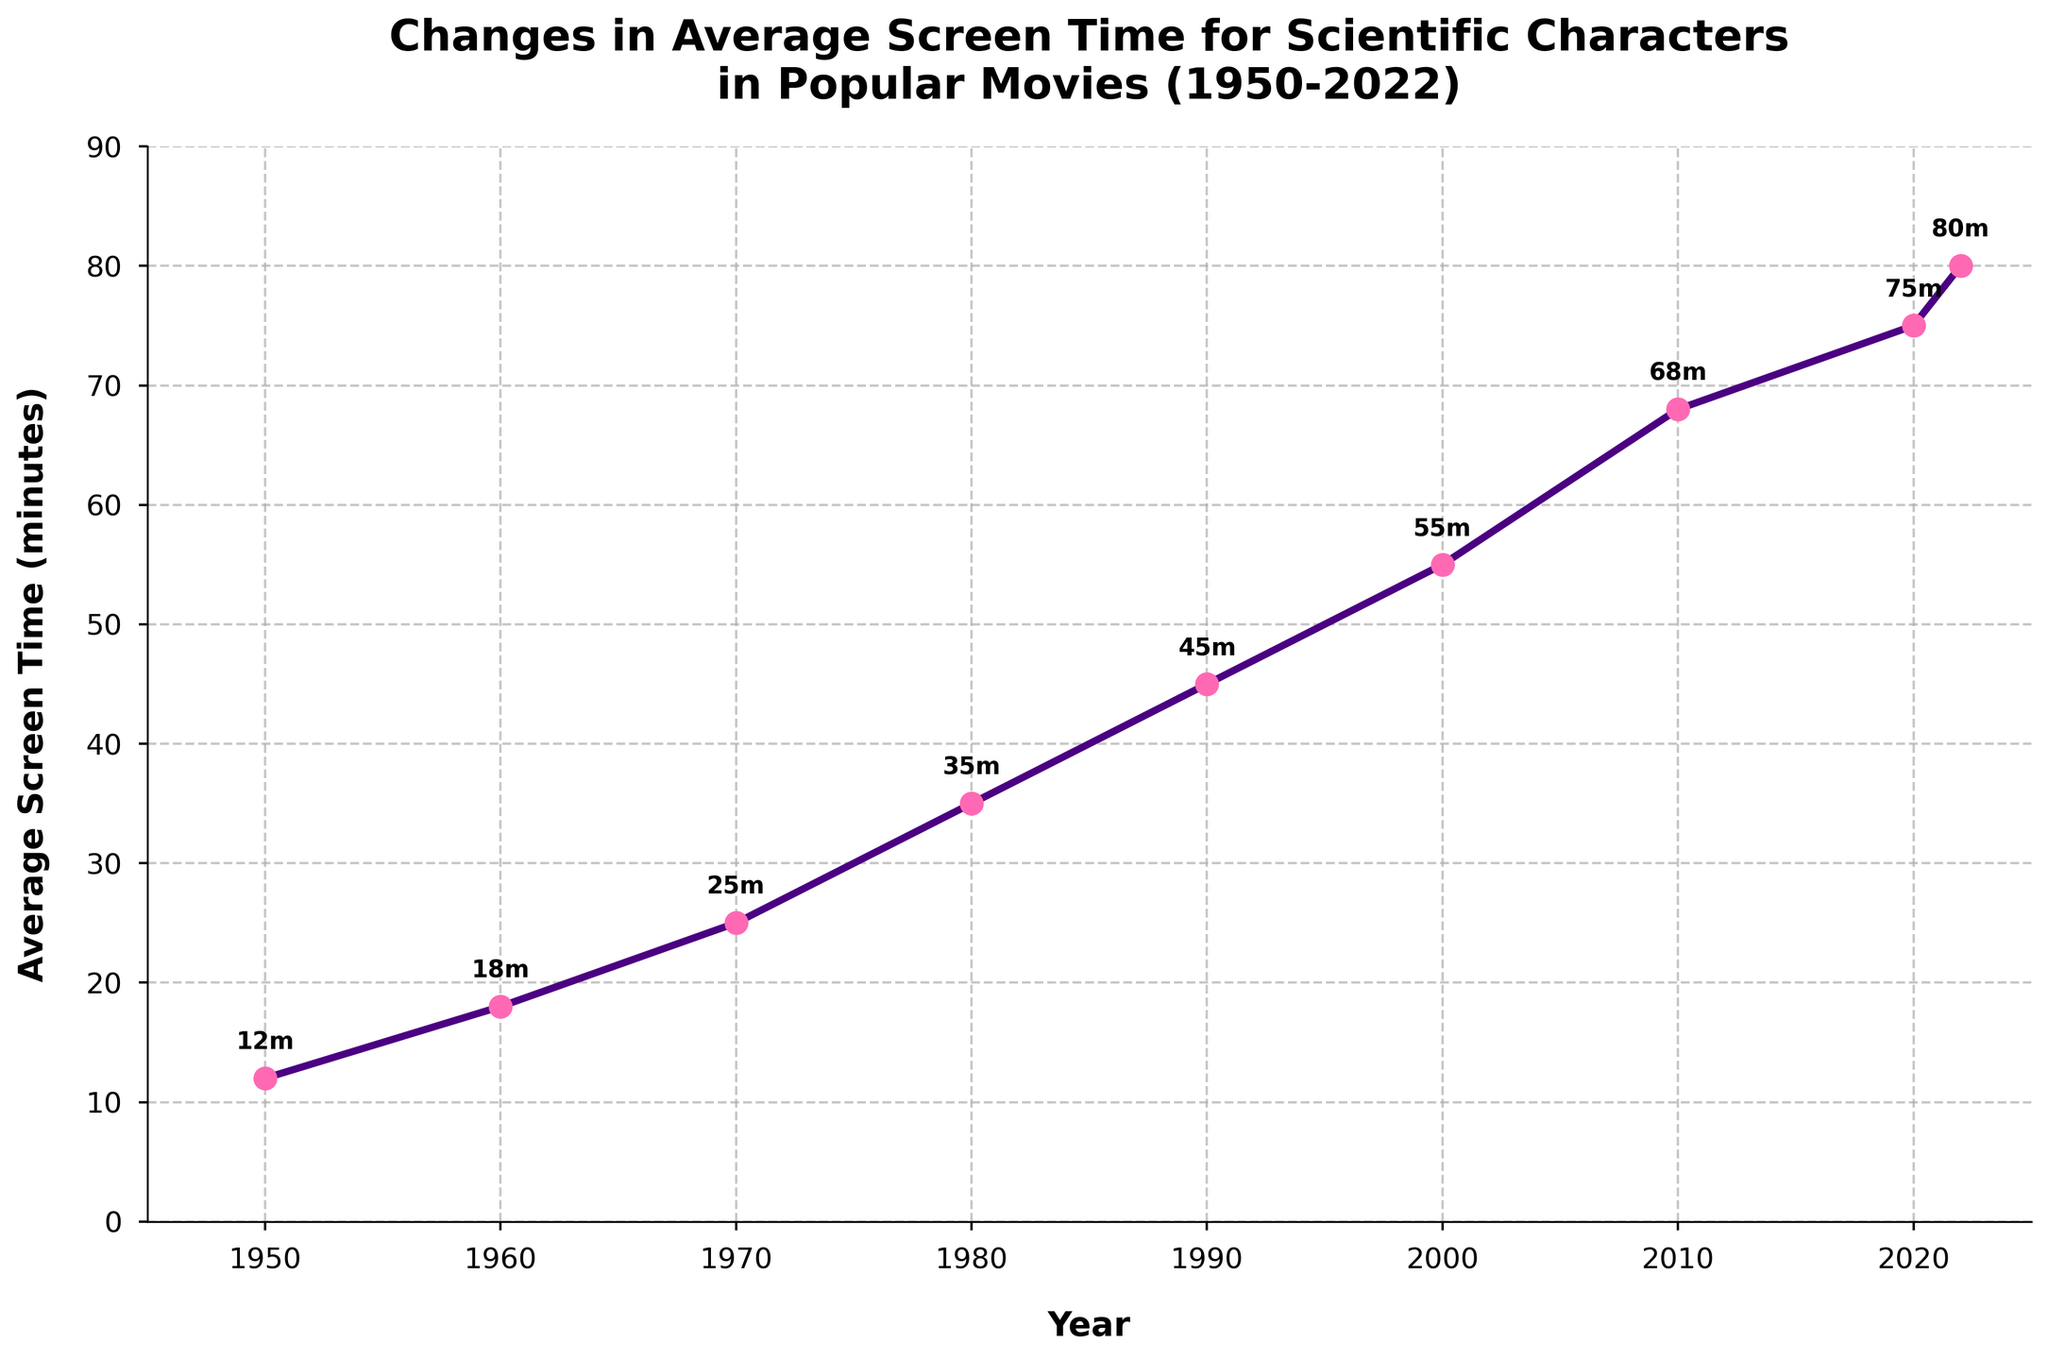What is the average screen time for scientific characters in popular movies in 2020? Look at the data point for the year 2020 on the plot. The y-axis value indicates the screen time for that year.
Answer: 75 minutes How much did the average screen time increase from 1950 to 2022? Identify the screen times for 1950 and 2022, then subtract the 1950 value from the 2022 value. 80 minutes (2022) - 12 minutes (1950) = 68 minutes
Answer: 68 minutes Which decade saw the largest increase in average screen time? Compare the increase in average screen time across decades by examining the data points on the plot. The increase from one decade to the next should be calculated. The 2010 to 2020 decade had an increase from 68 minutes to 75 minutes, and subsequently to 80 minutes in 2022.
Answer: 2010s How does the screen time in 1980 compare to that in 2000? Look at the screen times for the years 1980 and 2000 and compare them.
Answer: 1980 had 35 minutes and 2000 had 55 minutes. The screen time in 2000 is 20 minutes longer than in 1980 What is the overall trend in the average screen time for scientific characters from 1950 to 2022? Observe the general direction of the line plot from 1950 to 2022, noting if it increases, decreases, or remains constant.
Answer: Increasing trend Between which two consecutive data points does the largest single year increase occur? Calculate the difference in screen time for each consecutive year and identify the year with the largest difference. Evaluate changes: (1960-1950), (1970-1960), (1980-1970), etc. The increment is highest from 2010 to 2020 (68m to 75m).
Answer: 2010 to 2020 What is the median screen time of the dataset from 1950 to 2022? List all screen times in ascending order: 12, 18, 25, 35, 45, 55, 68, 75, 80. Since there are 9 values, the median is the middle value.
Answer: 45 minutes By how many minutes did the average screen time increase from 1970 to 1980? Identify the screen times for the years 1970 and 1980, then subtract the 1970 value from the 1980 value. 35 minutes (1980) - 25 minutes (1970) = 10 minutes.
Answer: 10 minutes 